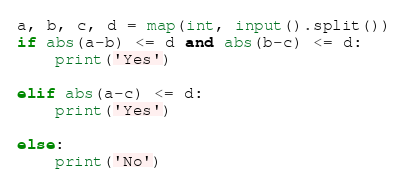Convert code to text. <code><loc_0><loc_0><loc_500><loc_500><_Python_>a, b, c, d = map(int, input().split())
if abs(a-b) <= d and abs(b-c) <= d:
    print('Yes')

elif abs(a-c) <= d:
    print('Yes')

else:
    print('No')</code> 